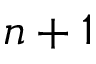<formula> <loc_0><loc_0><loc_500><loc_500>n + 1</formula> 